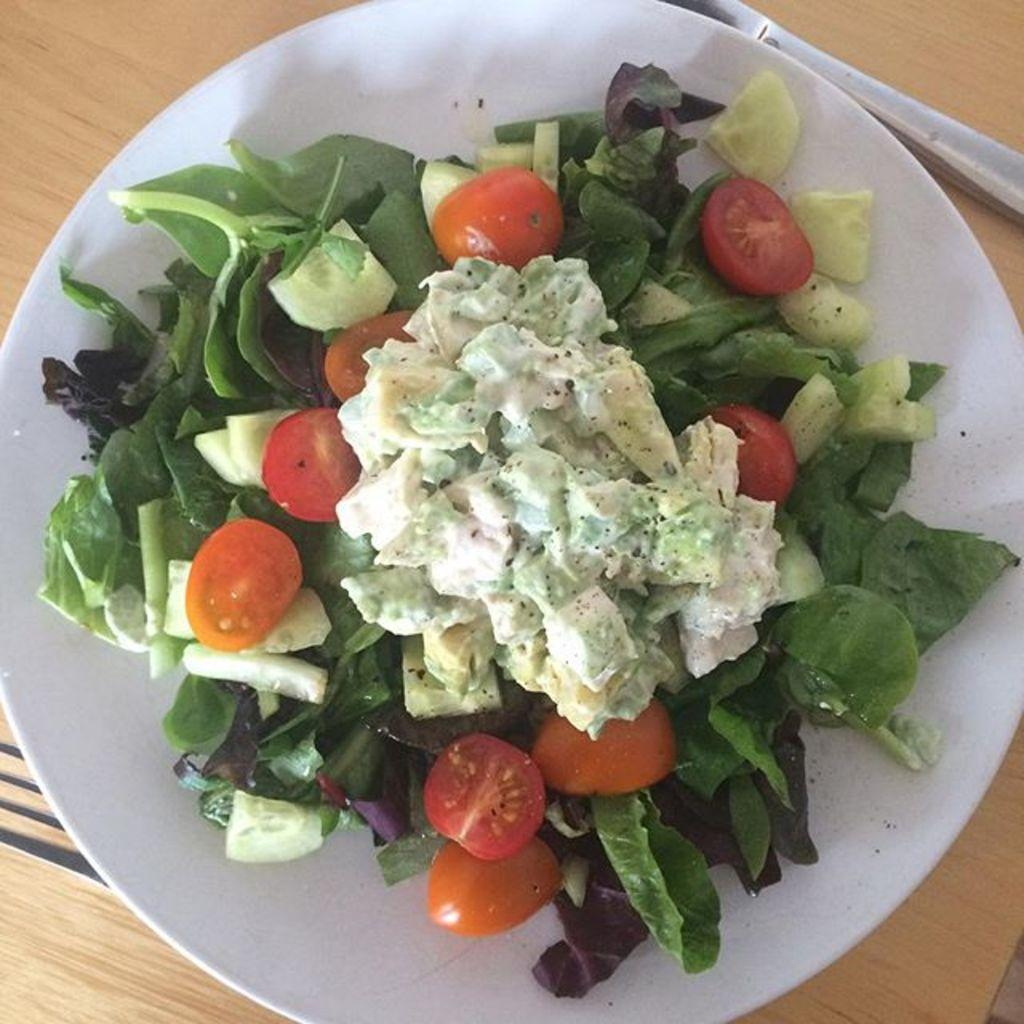What is on the plate that is visible in the image? There are different types of vegetables on the plate in the image. What color is the plate in the image? The plate is white. What type of vegetation is visible in the image? There are green leaves visible in the image. What utensil is present in the image? There is a fork in the image. How many sisters are sitting on the green leaves in the image? There are no sisters present in the image; it only features a plate with vegetables, green leaves, and a fork. 